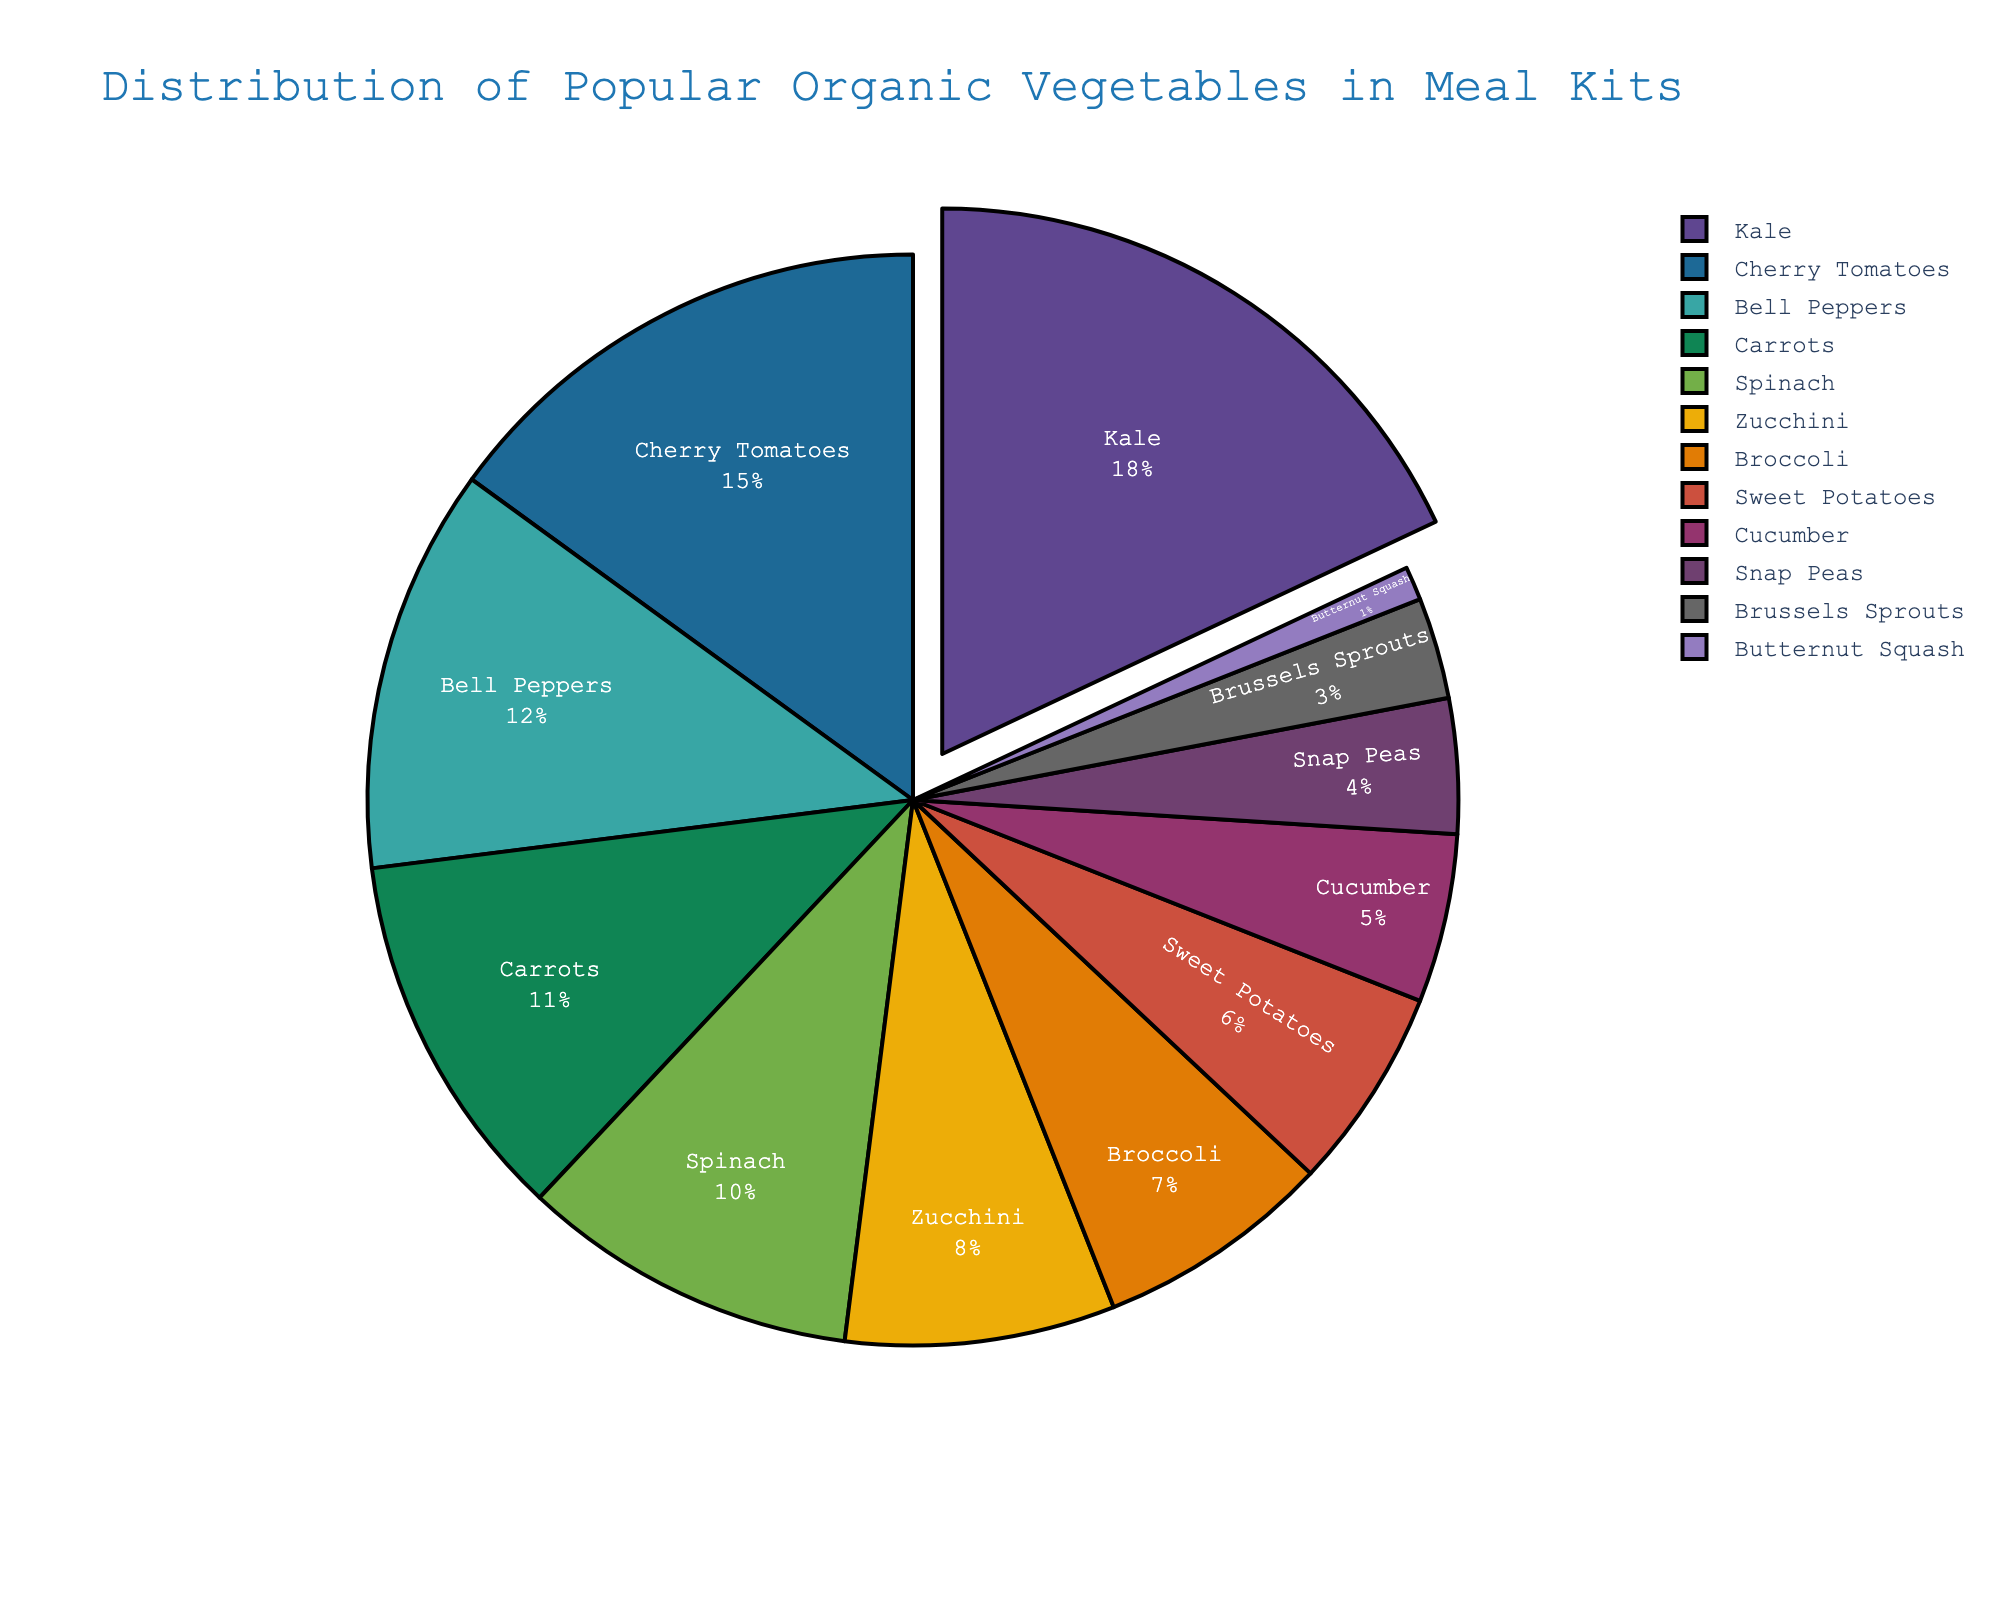Which vegetable has the highest percentage in the meal kits? The pie chart shows that Kale has the highest percentage among all vegetables in meal kits.
Answer: Kale How many vegetables have a percentage of 10% or higher? By looking at the pie chart, we can see that Kale, Cherry Tomatoes, Bell Peppers, Carrots, and Spinach all have percentages that are 10% or higher. Counting these adds up to 5 vegetables.
Answer: 5 Which vegetables make up a combined total of less than 10%? The vegetables that each individually show less than 10% in the pie chart are Zucchini, Broccoli, Sweet Potatoes, Cucumber, Snap Peas, Brussels Sprouts, and Butternut Squash.
Answer: Zucchini, Broccoli, Sweet Potatoes, Cucumber, Snap Peas, Brussels Sprouts, Butternut Squash Is the percentage of Bell Peppers greater than that of Carrots and Spinach combined? The percentage of Bell Peppers is 12%. Adding the percentages of Carrots and Spinach, we have 11% + 10% = 21%, which is greater than 12%.
Answer: No What is the difference in percentage between the vegetable with the highest and the one with the lowest distribution? Kale has the highest percentage at 18%, and Butternut Squash has the lowest at 1%. The difference is 18% - 1% = 17%.
Answer: 17% Do Kale and Cherry Tomatoes together make up more than a third of the total distribution? The percentage for Kale is 18%, and for Cherry Tomatoes, it is 15%. Together, these total 18% + 15% = 33%, which is exactly one-third of 100%. They do not make up more than a third.
Answer: No What is the combined percentage for all leafy greens (Kale, Spinach)? Kale has a percentage of 18% and Spinach has 10%. Adding these together gives us 18% + 10% = 28%.
Answer: 28% Which vegetable's segment is colored differently than its adjacent segments due to having the smallest percentage? The vegetable with the smallest percentage is Butternut Squash with 1%, and it is visually set apart by its color and smaller segment.
Answer: Butternut Squash Compare the percentages of the top three vegetables in the meal kits. The top three vegetables by percentage are Kale (18%), Cherry Tomatoes (15%), and Bell Peppers (12%).
Answer: Kale > Cherry Tomatoes > Bell Peppers 